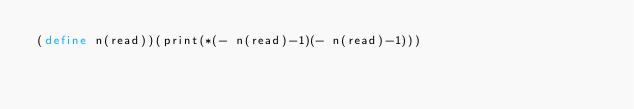<code> <loc_0><loc_0><loc_500><loc_500><_Scheme_>(define n(read))(print(*(- n(read)-1)(- n(read)-1)))</code> 